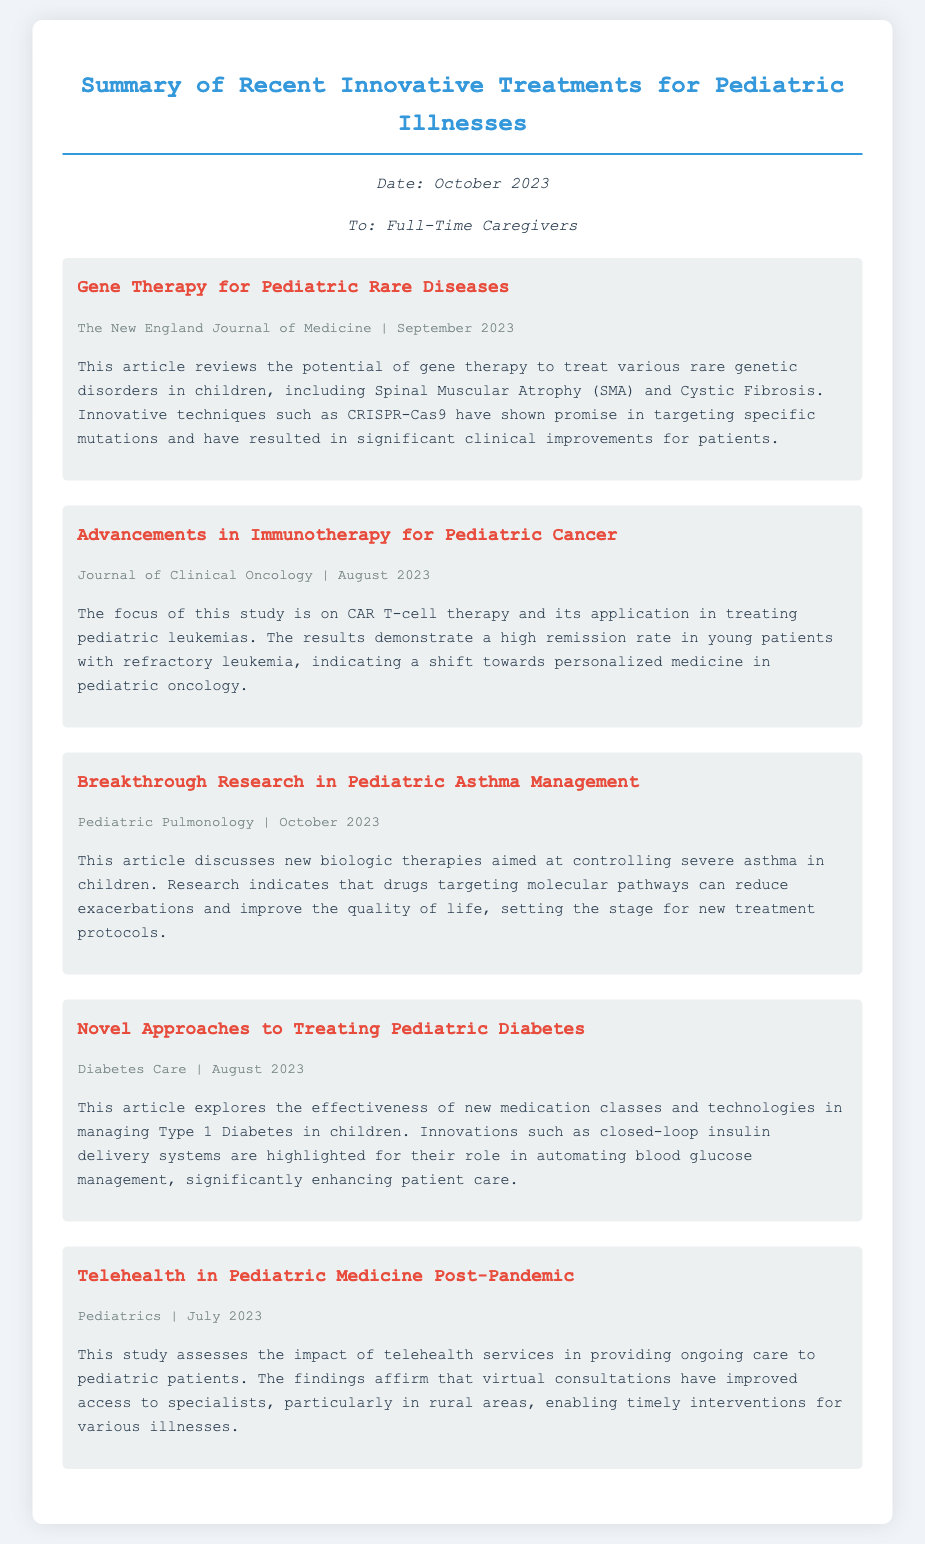What is the title of the first article? The title of the first article is mentioned in the document under the section for that article.
Answer: Gene Therapy for Pediatric Rare Diseases Which journal published the article on immunotherapy for pediatric cancer? The name of the journal is provided in the article's metadata section.
Answer: Journal of Clinical Oncology What innovative technique is mentioned for treating pediatric rare diseases? The text highlights specific innovative techniques used within the article summary.
Answer: CRISPR-Cas9 What new approach is discussed for managing Type 1 Diabetes in children? This approach is explained in the article summary regarding its effectiveness and innovations.
Answer: Closed-loop insulin delivery systems In which month was the article on pediatric asthma management published? The publishing date is indicated in the article's metadata section.
Answer: October 2023 How does telehealth impact access to specialists for pediatric patients? This is covered in the findings of the study discussed in the document.
Answer: Improved access What was the remission rate reported for CAR T-cell therapy? This detail about the therapy's success rate is summarized in that article section.
Answer: High remission rate Which condition does the article on diabetes specifically focus on? This condition is explicitly identified in the article summary regarding its management.
Answer: Type 1 Diabetes 